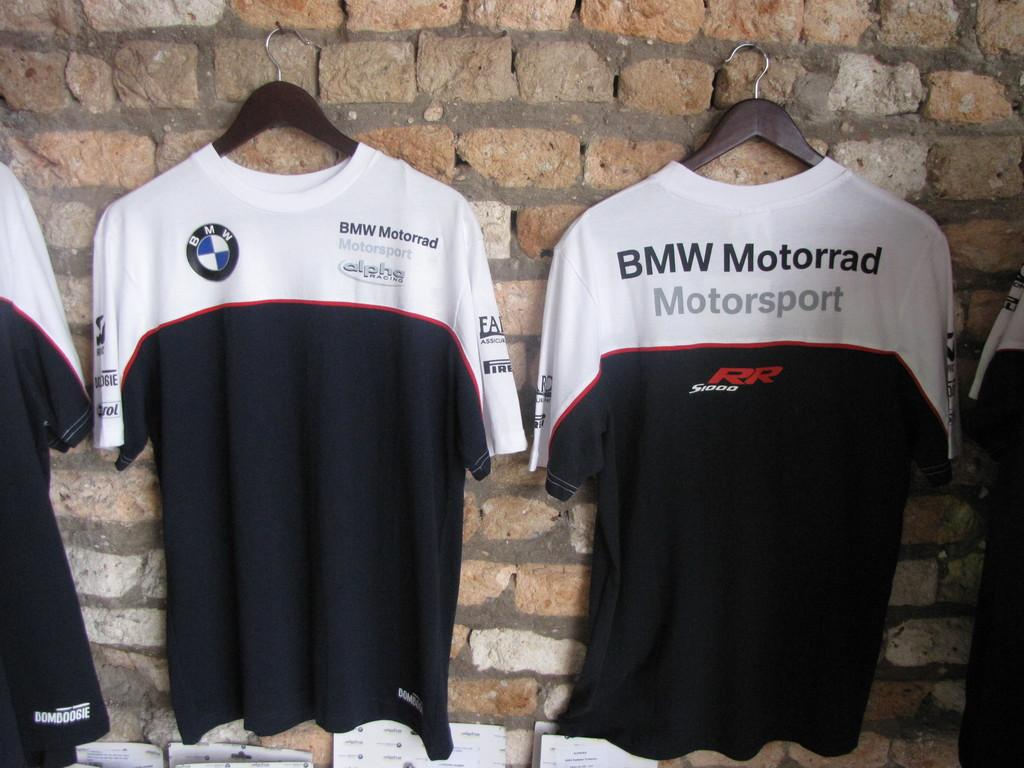<image>
Offer a succinct explanation of the picture presented. BMW Mororrad Motorsport tops hanging on a wall together. 